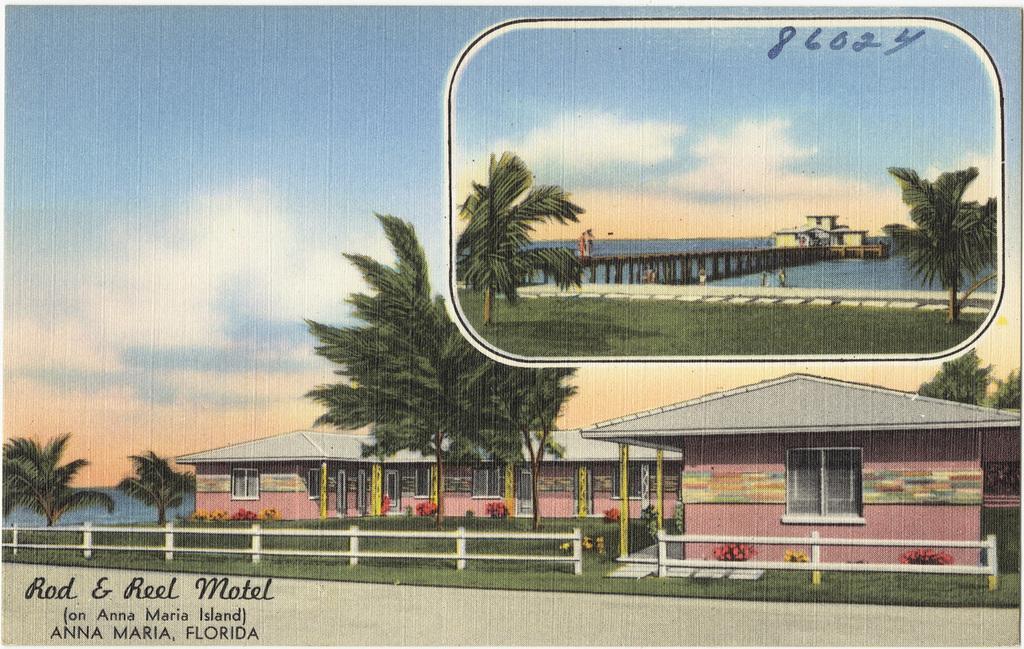How would you summarize this image in a sentence or two? In this image I can see houses and in front of the houses I can see trees and the sky, bridge and lake at the top. 